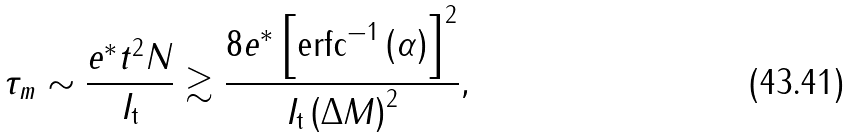<formula> <loc_0><loc_0><loc_500><loc_500>\tau _ { m } \sim \frac { e ^ { \ast } t ^ { 2 } N } { I _ { \text {t} } } \gtrsim \frac { 8 e ^ { \ast } \left [ \text {erfc} ^ { - 1 } \left ( \alpha \right ) \right ] ^ { 2 } } { I _ { \text {t} } \left ( \Delta M \right ) ^ { 2 } } ,</formula> 